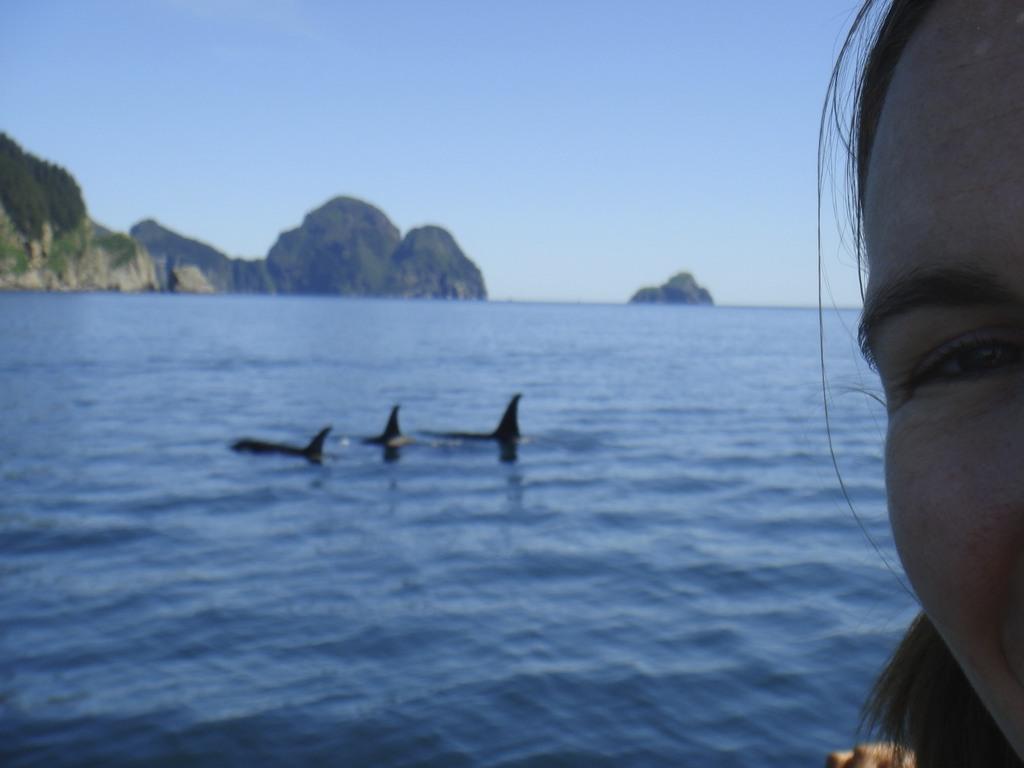How would you summarize this image in a sentence or two? In this image I can see the person's face, background I can see few aquatic animals in the water, trees in green color, few rocks and the sky is in blue color. 